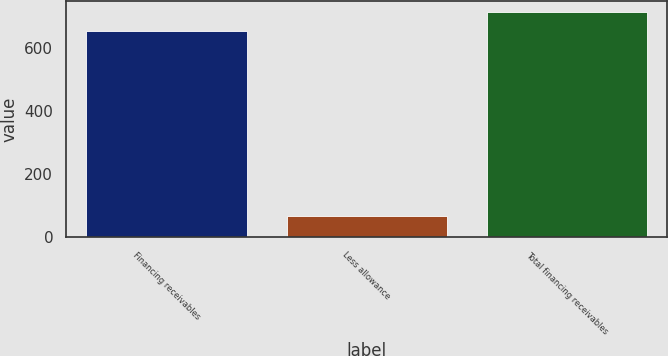Convert chart. <chart><loc_0><loc_0><loc_500><loc_500><bar_chart><fcel>Financing receivables<fcel>Less allowance<fcel>Total financing receivables<nl><fcel>654<fcel>67<fcel>715.4<nl></chart> 